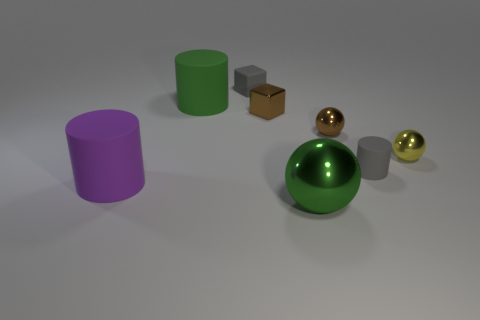Is the green cylinder made of the same material as the ball that is in front of the yellow object?
Provide a short and direct response. No. Does the tiny object behind the shiny block have the same color as the small rubber cylinder?
Make the answer very short. Yes. There is a tiny thing that is both on the left side of the tiny gray rubber cylinder and in front of the brown metal cube; what is its material?
Offer a very short reply. Metal. The green sphere has what size?
Your answer should be compact. Large. Is the color of the small matte cylinder the same as the tiny matte thing that is behind the tiny gray cylinder?
Your answer should be very brief. Yes. There is a green object in front of the yellow metal thing; does it have the same size as the green thing behind the purple object?
Provide a succinct answer. Yes. The ball to the left of the brown shiny sphere is what color?
Keep it short and to the point. Green. Is the number of small brown metal spheres that are to the left of the tiny brown metallic ball less than the number of big blue shiny balls?
Offer a terse response. No. Is the material of the small gray cylinder the same as the purple object?
Your answer should be very brief. Yes. What size is the brown thing that is the same shape as the green shiny object?
Ensure brevity in your answer.  Small. 